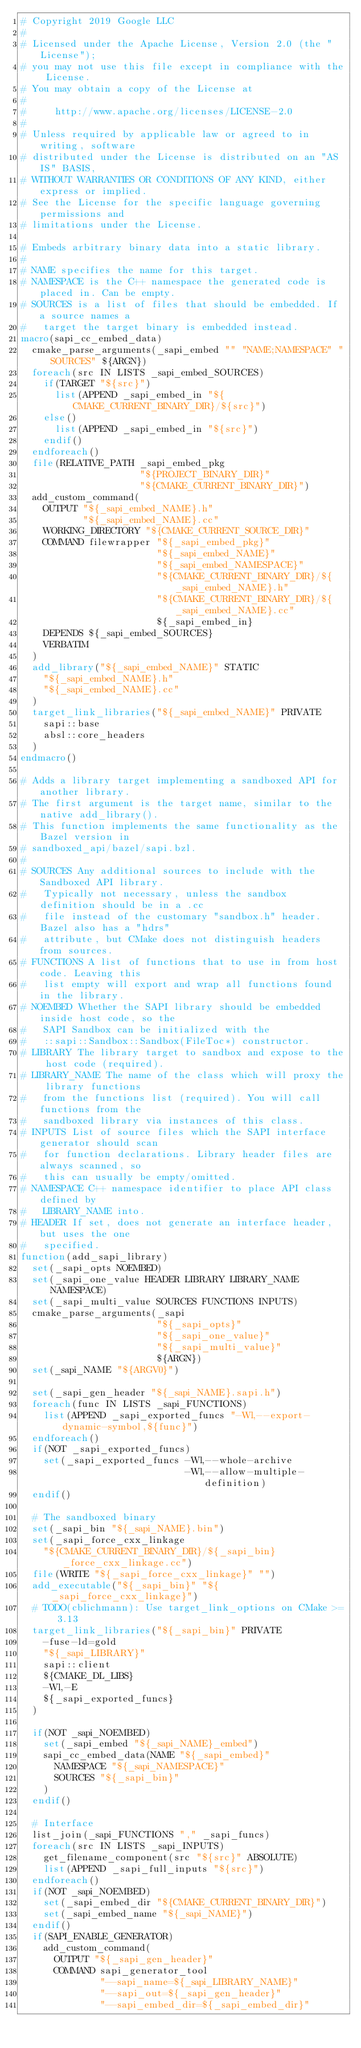<code> <loc_0><loc_0><loc_500><loc_500><_CMake_># Copyright 2019 Google LLC
#
# Licensed under the Apache License, Version 2.0 (the "License");
# you may not use this file except in compliance with the License.
# You may obtain a copy of the License at
#
#     http://www.apache.org/licenses/LICENSE-2.0
#
# Unless required by applicable law or agreed to in writing, software
# distributed under the License is distributed on an "AS IS" BASIS,
# WITHOUT WARRANTIES OR CONDITIONS OF ANY KIND, either express or implied.
# See the License for the specific language governing permissions and
# limitations under the License.

# Embeds arbitrary binary data into a static library.
#
# NAME specifies the name for this target.
# NAMESPACE is the C++ namespace the generated code is placed in. Can be empty.
# SOURCES is a list of files that should be embedded. If a source names a
#   target the target binary is embedded instead.
macro(sapi_cc_embed_data)
  cmake_parse_arguments(_sapi_embed "" "NAME;NAMESPACE" "SOURCES" ${ARGN})
  foreach(src IN LISTS _sapi_embed_SOURCES)
    if(TARGET "${src}")
      list(APPEND _sapi_embed_in "${CMAKE_CURRENT_BINARY_DIR}/${src}")
    else()
      list(APPEND _sapi_embed_in "${src}")
    endif()
  endforeach()
  file(RELATIVE_PATH _sapi_embed_pkg
                     "${PROJECT_BINARY_DIR}"
                     "${CMAKE_CURRENT_BINARY_DIR}")
  add_custom_command(
    OUTPUT "${_sapi_embed_NAME}.h"
           "${_sapi_embed_NAME}.cc"
    WORKING_DIRECTORY "${CMAKE_CURRENT_SOURCE_DIR}"
    COMMAND filewrapper "${_sapi_embed_pkg}"
                        "${_sapi_embed_NAME}"
                        "${_sapi_embed_NAMESPACE}"
                        "${CMAKE_CURRENT_BINARY_DIR}/${_sapi_embed_NAME}.h"
                        "${CMAKE_CURRENT_BINARY_DIR}/${_sapi_embed_NAME}.cc"
                        ${_sapi_embed_in}
    DEPENDS ${_sapi_embed_SOURCES}
    VERBATIM
  )
  add_library("${_sapi_embed_NAME}" STATIC
    "${_sapi_embed_NAME}.h"
    "${_sapi_embed_NAME}.cc"
  )
  target_link_libraries("${_sapi_embed_NAME}" PRIVATE
    sapi::base
    absl::core_headers
  )
endmacro()

# Adds a library target implementing a sandboxed API for another library.
# The first argument is the target name, similar to the native add_library().
# This function implements the same functionality as the Bazel version in
# sandboxed_api/bazel/sapi.bzl.
#
# SOURCES Any additional sources to include with the Sandboxed API library.
#   Typically not necessary, unless the sandbox definition should be in a .cc
#   file instead of the customary "sandbox.h" header. Bazel also has a "hdrs"
#   attribute, but CMake does not distinguish headers from sources.
# FUNCTIONS A list of functions that to use in from host code. Leaving this
#   list empty will export and wrap all functions found in the library.
# NOEMBED Whether the SAPI library should be embedded inside host code, so the
#   SAPI Sandbox can be initialized with the
#   ::sapi::Sandbox::Sandbox(FileToc*) constructor.
# LIBRARY The library target to sandbox and expose to the host code (required).
# LIBRARY_NAME The name of the class which will proxy the library functions
#   from the functions list (required). You will call functions from the
#   sandboxed library via instances of this class.
# INPUTS List of source files which the SAPI interface generator should scan
#   for function declarations. Library header files are always scanned, so
#   this can usually be empty/omitted.
# NAMESPACE C++ namespace identifier to place API class defined by
#   LIBRARY_NAME into.
# HEADER If set, does not generate an interface header, but uses the one
#   specified.
function(add_sapi_library)
  set(_sapi_opts NOEMBED)
  set(_sapi_one_value HEADER LIBRARY LIBRARY_NAME NAMESPACE)
  set(_sapi_multi_value SOURCES FUNCTIONS INPUTS)
  cmake_parse_arguments(_sapi
                        "${_sapi_opts}"
                        "${_sapi_one_value}"
                        "${_sapi_multi_value}"
                        ${ARGN})
  set(_sapi_NAME "${ARGV0}")

  set(_sapi_gen_header "${_sapi_NAME}.sapi.h")
  foreach(func IN LISTS _sapi_FUNCTIONS)
    list(APPEND _sapi_exported_funcs "-Wl,--export-dynamic-symbol,${func}")
  endforeach()
  if(NOT _sapi_exported_funcs)
    set(_sapi_exported_funcs -Wl,--whole-archive
                             -Wl,--allow-multiple-definition)
  endif()

  # The sandboxed binary
  set(_sapi_bin "${_sapi_NAME}.bin")
  set(_sapi_force_cxx_linkage
    "${CMAKE_CURRENT_BINARY_DIR}/${_sapi_bin}_force_cxx_linkage.cc")
  file(WRITE "${_sapi_force_cxx_linkage}" "")
  add_executable("${_sapi_bin}" "${_sapi_force_cxx_linkage}")
  # TODO(cblichmann): Use target_link_options on CMake >= 3.13
  target_link_libraries("${_sapi_bin}" PRIVATE
    -fuse-ld=gold
    "${_sapi_LIBRARY}"
    sapi::client
    ${CMAKE_DL_LIBS}
    -Wl,-E
    ${_sapi_exported_funcs}
  )

  if(NOT _sapi_NOEMBED)
    set(_sapi_embed "${_sapi_NAME}_embed")
    sapi_cc_embed_data(NAME "${_sapi_embed}"
      NAMESPACE "${_sapi_NAMESPACE}"
      SOURCES "${_sapi_bin}"
    )
  endif()

  # Interface
  list_join(_sapi_FUNCTIONS "," _sapi_funcs)
  foreach(src IN LISTS _sapi_INPUTS)
    get_filename_component(src "${src}" ABSOLUTE)
    list(APPEND _sapi_full_inputs "${src}")
  endforeach()
  if(NOT _sapi_NOEMBED)
    set(_sapi_embed_dir "${CMAKE_CURRENT_BINARY_DIR}")
    set(_sapi_embed_name "${_sapi_NAME}")
  endif()
  if(SAPI_ENABLE_GENERATOR)
    add_custom_command(
      OUTPUT "${_sapi_gen_header}"
      COMMAND sapi_generator_tool
              "--sapi_name=${_sapi_LIBRARY_NAME}"
              "--sapi_out=${_sapi_gen_header}"
              "--sapi_embed_dir=${_sapi_embed_dir}"</code> 